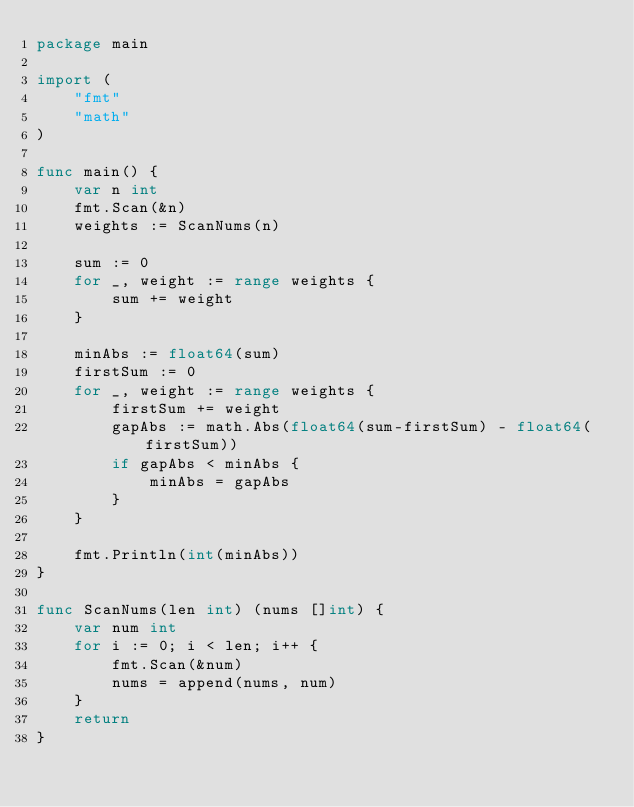Convert code to text. <code><loc_0><loc_0><loc_500><loc_500><_Go_>package main

import (
	"fmt"
	"math"
)

func main() {
	var n int
	fmt.Scan(&n)
	weights := ScanNums(n)

	sum := 0
	for _, weight := range weights {
		sum += weight
	}

	minAbs := float64(sum)
	firstSum := 0
	for _, weight := range weights {
		firstSum += weight
		gapAbs := math.Abs(float64(sum-firstSum) - float64(firstSum))
		if gapAbs < minAbs {
			minAbs = gapAbs
		}
	}

	fmt.Println(int(minAbs))
}

func ScanNums(len int) (nums []int) {
	var num int
	for i := 0; i < len; i++ {
		fmt.Scan(&num)
		nums = append(nums, num)
	}
	return
}
</code> 